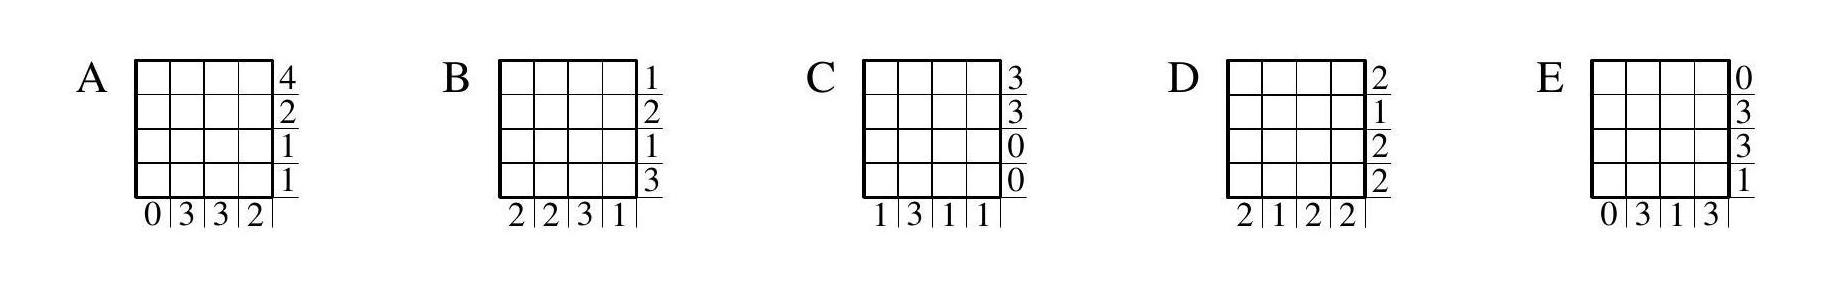Can you identify any inconsistency in the count of red cells within the choices? Upon reviewing the tables A to E in comparison to the $4 \times 4$ grid, it's evident that each table has inconsistencies. For instance, options A and E have different total counts of red cells when adding rows and columns, which is not possible. Options B, C, and D either have rows or columns with uniform counts, implying an unrealistic painting scenario given the discrete nature of painting individual cells. Therefore, each choice has at least one discrepancy. 